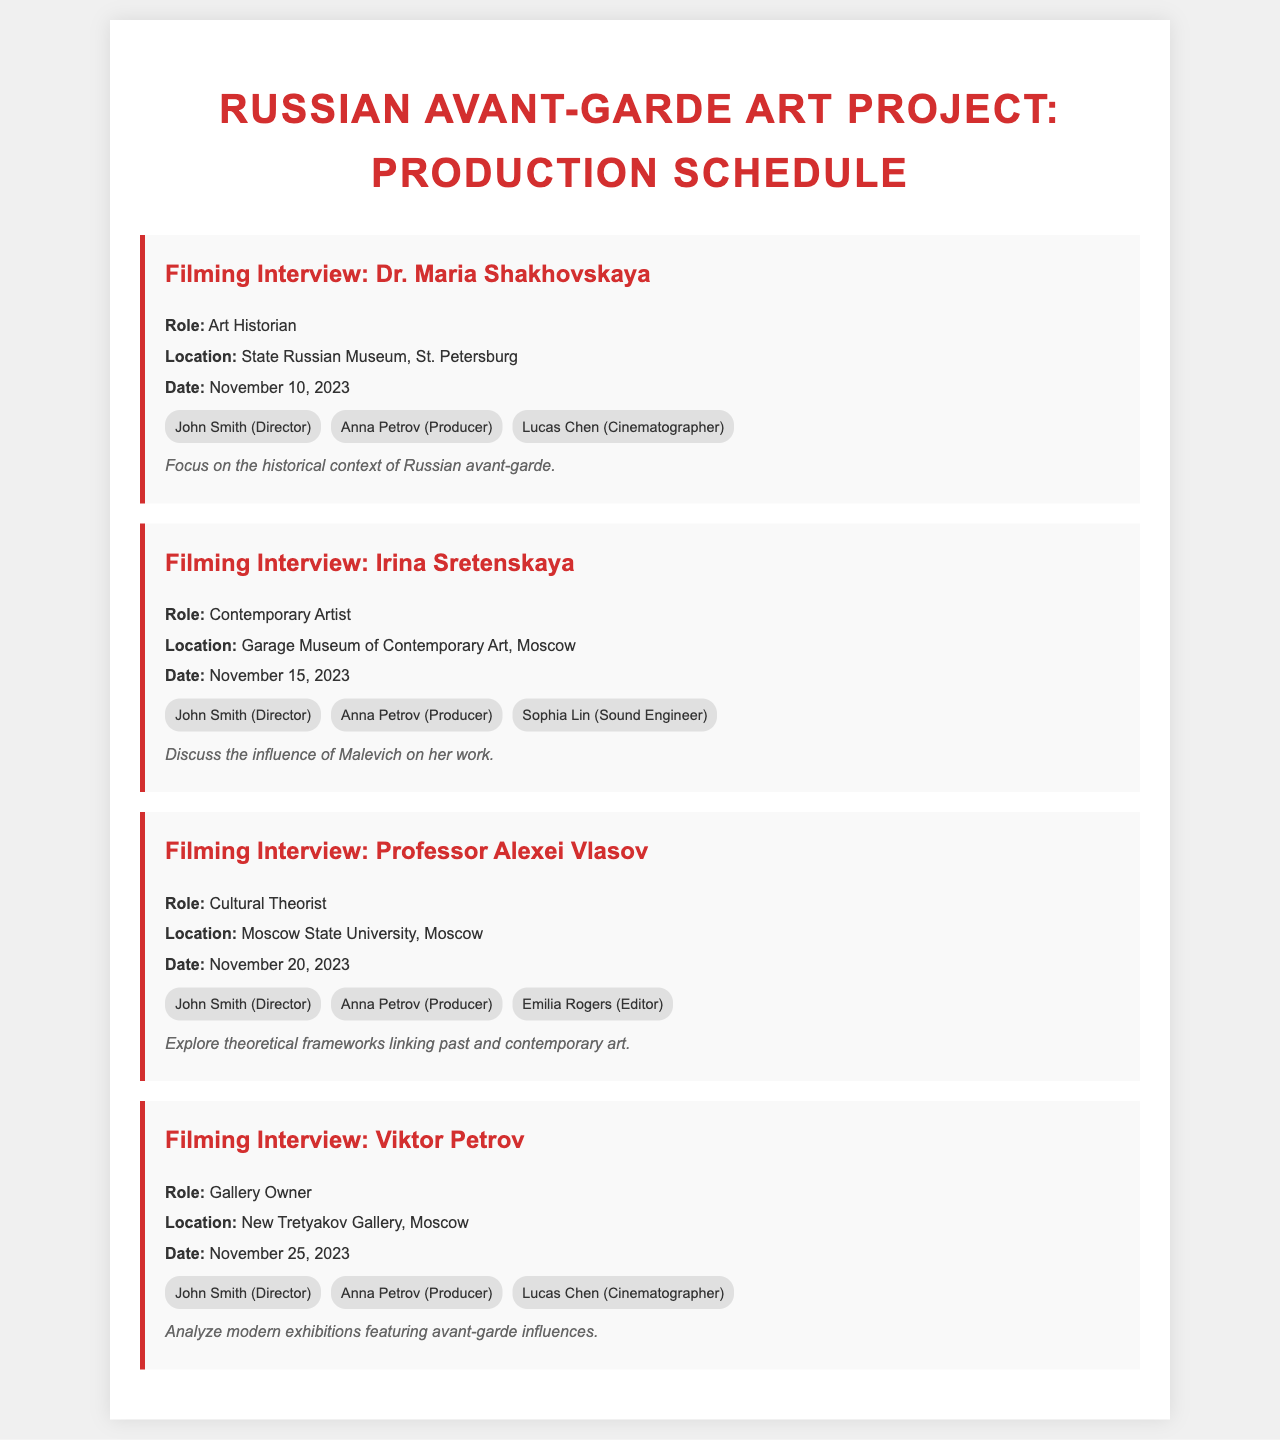What is the date of the interview with Dr. Maria Shakhovskaya? The document states that the interview with Dr. Maria Shakhovskaya is scheduled for November 10, 2023.
Answer: November 10, 2023 Who is the cinematographer for the interview with Irina Sretenskaya? According to the document, Lucas Chen is assigned as the cinematographer for the interview with Irina Sretenskaya.
Answer: Lucas Chen What location is designated for filming Viktor Petrov's interview? The document specifies that the interview with Viktor Petrov will take place at the New Tretyakov Gallery in Moscow.
Answer: New Tretyakov Gallery, Moscow What is the primary focus of the interview with Professor Alexei Vlasov? The document indicates that the focus is on exploring theoretical frameworks linking past and contemporary art.
Answer: Theoretical frameworks linking past and contemporary art How many personnel are assigned to the interview with Dr. Maria Shakhovskaya? The document shows that three personnel are assigned to the interview with Dr. Maria Shakhovskaya.
Answer: Three What role does Irina Sretenskaya hold? The document lists her role as a Contemporary Artist.
Answer: Contemporary Artist What is a key feature of the interview schedule format? The document consistently includes the role, location, date, personnel, and notes for each interview.
Answer: Consistent format with role, location, date, personnel, and notes When is the interview with Viktor Petrov scheduled? The document states that the interview with Viktor Petrov is scheduled for November 25, 2023.
Answer: November 25, 2023 What museum will Professor Alexei Vlasov's interview be held in? The document notes that the interview will be held at Moscow State University.
Answer: Moscow State University 